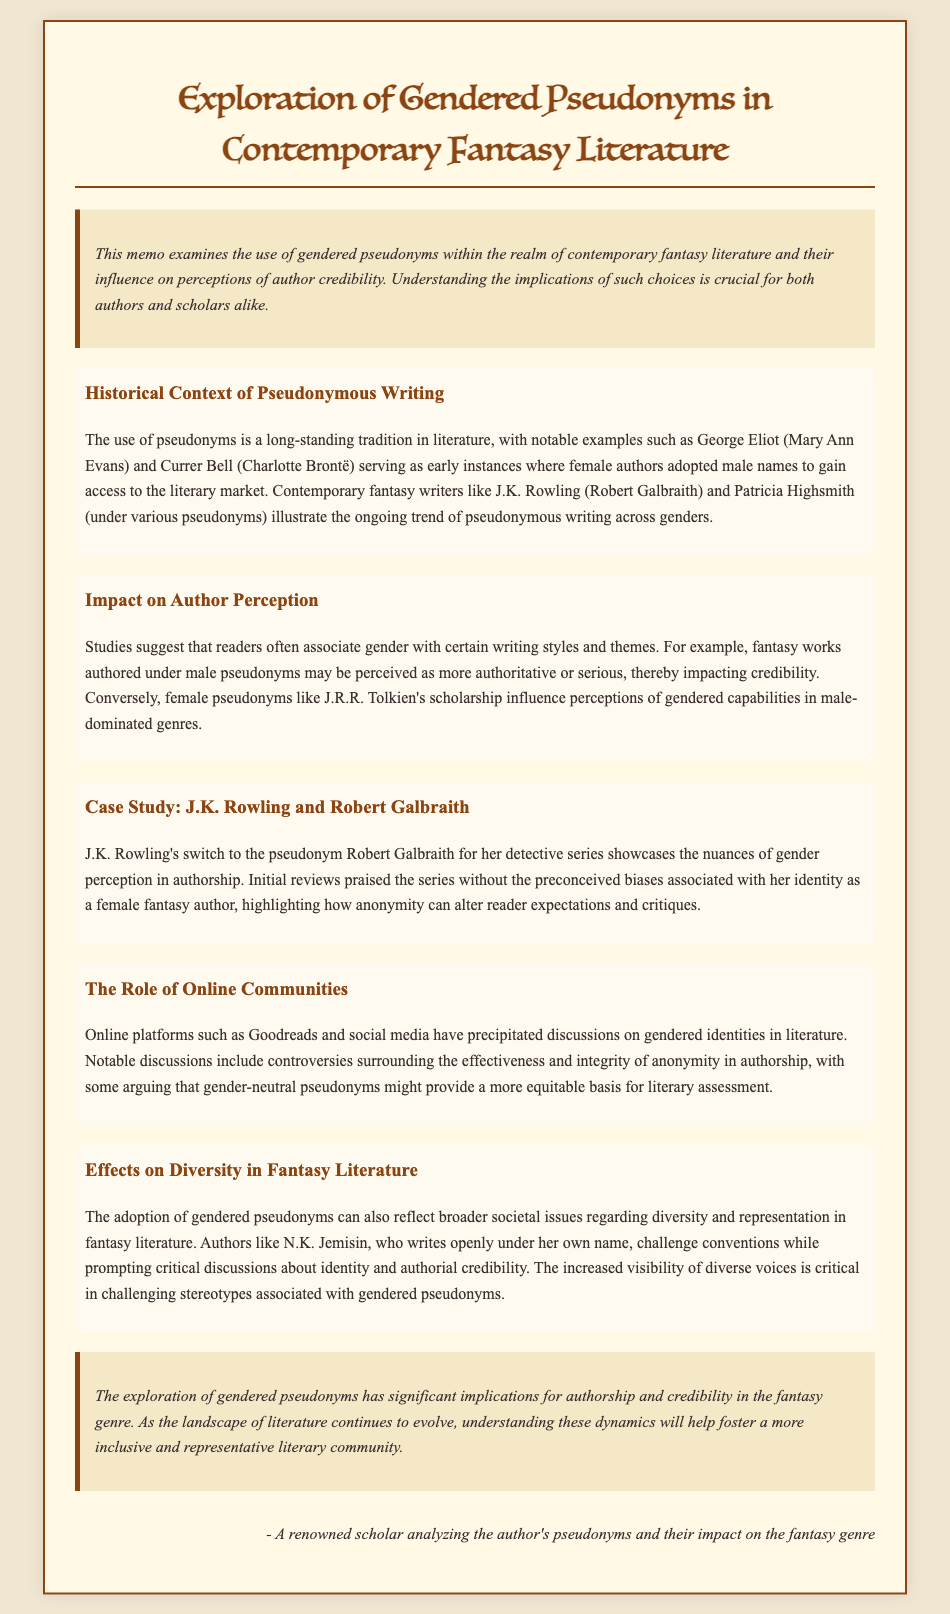What is the primary focus of the memo? The memo's primary focus is the examination of gendered pseudonyms in contemporary fantasy literature and their impact on author credibility.
Answer: gendered pseudonyms in contemporary fantasy literature Who is used as an example of a female author adopting a male pseudonym? In the memo, J.K. Rowling is mentioned as an example of a female author who used the male pseudonym Robert Galbraith.
Answer: J.K. Rowling What effect do male pseudonyms have on perceived author credibility? The memo states that fantasy works authored under male pseudonyms may be perceived as more authoritative or serious, impacting credibility.
Answer: more authoritative or serious What does the case study of J.K. Rowling illustrate? The case study illustrates how anonymity can alter reader expectations and critiques, showing nuances of gender perception in authorship.
Answer: anonymity can alter reader expectations Which online platform is mentioned as facilitating discussions on gendered identities? The memo mentions Goodreads as an online platform that has precipitated discussions surrounding gendered identities in literature.
Answer: Goodreads How does N.K. Jemisin challenge conventions in fantasy literature? N.K. Jemisin challenges conventions by writing openly under her own name, promoting critical discussions about identity and authorial credibility.
Answer: writing openly under her own name What is a broader societal issue reflected by gendered pseudonyms according to the memo? The adoption of gendered pseudonyms reflects broader societal issues regarding diversity and representation in fantasy literature.
Answer: diversity and representation What was the conclusion regarding the exploration of gendered pseudonyms? The conclusion states that understanding the dynamics of gendered pseudonyms will help foster a more inclusive and representative literary community.
Answer: foster a more inclusive and representative literary community 